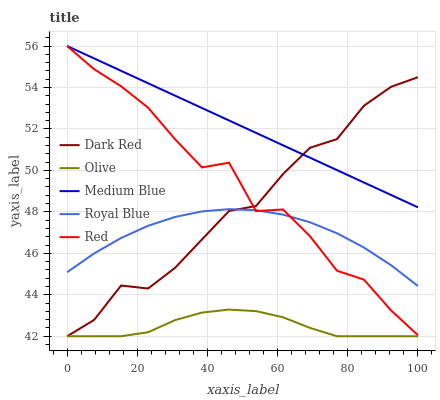Does Olive have the minimum area under the curve?
Answer yes or no. Yes. Does Medium Blue have the maximum area under the curve?
Answer yes or no. Yes. Does Dark Red have the minimum area under the curve?
Answer yes or no. No. Does Dark Red have the maximum area under the curve?
Answer yes or no. No. Is Medium Blue the smoothest?
Answer yes or no. Yes. Is Red the roughest?
Answer yes or no. Yes. Is Dark Red the smoothest?
Answer yes or no. No. Is Dark Red the roughest?
Answer yes or no. No. Does Olive have the lowest value?
Answer yes or no. Yes. Does Medium Blue have the lowest value?
Answer yes or no. No. Does Red have the highest value?
Answer yes or no. Yes. Does Dark Red have the highest value?
Answer yes or no. No. Is Olive less than Medium Blue?
Answer yes or no. Yes. Is Medium Blue greater than Olive?
Answer yes or no. Yes. Does Olive intersect Dark Red?
Answer yes or no. Yes. Is Olive less than Dark Red?
Answer yes or no. No. Is Olive greater than Dark Red?
Answer yes or no. No. Does Olive intersect Medium Blue?
Answer yes or no. No. 